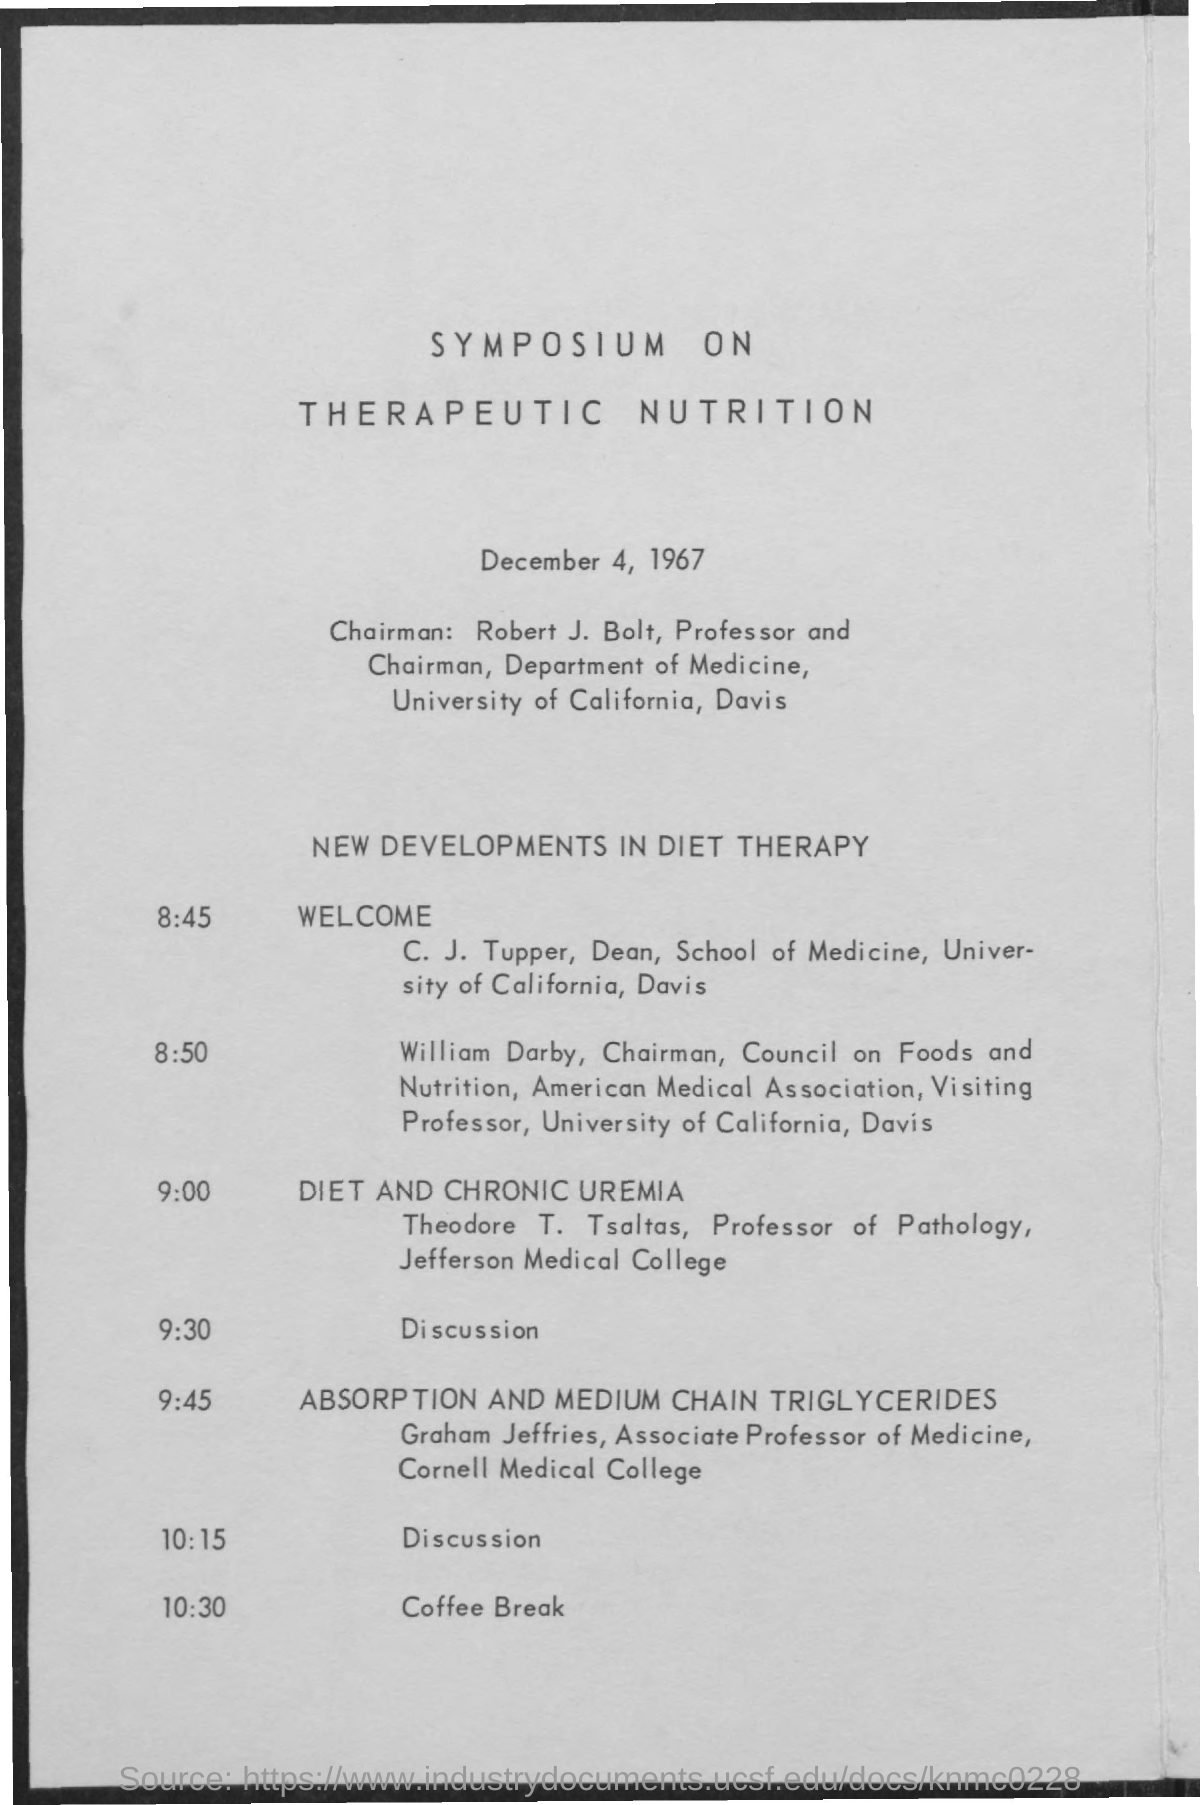What is the title of the document?
Your response must be concise. Symposium on Therapeutic Nutrition. What is the date mentioned in the document?
Make the answer very short. DECEMBER 4, 1967. Who is the Chairman?
Keep it short and to the point. ROBERT J. BOLT. Who is the chairman of the department of medicine?
Make the answer very short. Robert J. Bolt. Who is the chairman of the council on foods and nutrition?
Give a very brief answer. WILLIAM DARBY. Who is the associate professor of medicine at Cornell medical college?
Keep it short and to the point. GRAHAM JEFFRIES. Who is the professor of pathology at Jefferson medical college?
Ensure brevity in your answer.  THEODORE T. TSALTAS. 